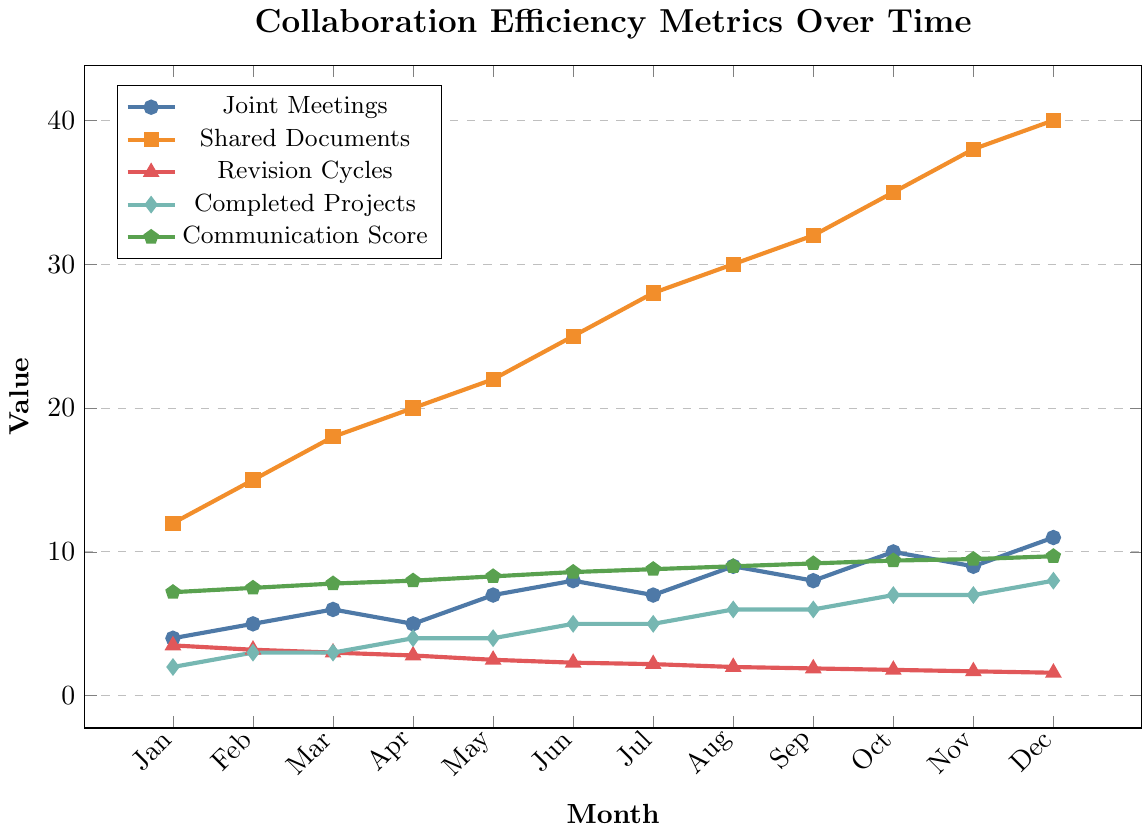What is the trend in the number of Joint Meetings over the months? The number of Joint Meetings starts at 4 in January, increases to 6 in March, sees minor fluctuation until it hits 9 in August, and peaks at 11 in December.
Answer: Increasing trend Which month had the highest Communication Score? The highest Communication Score is in December, where it reaches 9.7.
Answer: December By how much did the number of Shared Documents increase from January to December? The number of Shared Documents in January is 12 and in December it reaches 40. The increase is 40 - 12 = 28.
Answer: 28 What is the difference in Revision Cycles between the months with the maximum and minimum scores? The highest number of Revision Cycles is in January at 3.5 and the lowest is in December at 1.6. The difference is 3.5 - 1.6 = 1.9.
Answer: 1.9 Which metric had the most significant increase over the year? Comparing the initial and final values for all metrics: Joint Meetings (4 to 11), Shared Documents (12 to 40), Revision Cycles (3.5 to 1.6), Completed Projects (2 to 8), Communication Score (7.2 to 9.7), Shared Documents increased the most significantly from 12 to 40, an increase of 28.
Answer: Shared Documents When were the number of Completed Projects equal to the number of Joint Meetings? Both the Completed Projects and Joint Meetings are equal to 5 in June and July.
Answer: June, July What is the average Communication Score for the entire year? The Communication Scores are: 7.2, 7.5, 7.8, 8.0, 8.3, 8.6, 8.8, 9.0, 9.2, 9.4, 9.5, 9.7. The sum is 101 and there are 12 months, so the average is 101 / 12 = 8.42.
Answer: 8.42 In which months did Revision Cycles drop below 3? Revision Cycles drop below 3 starting from April to December: April (2.8), May (2.5), June (2.3), July (2.2), August (2.0), September (1.9), October (1.8), November (1.7), December (1.6).
Answer: April to December 